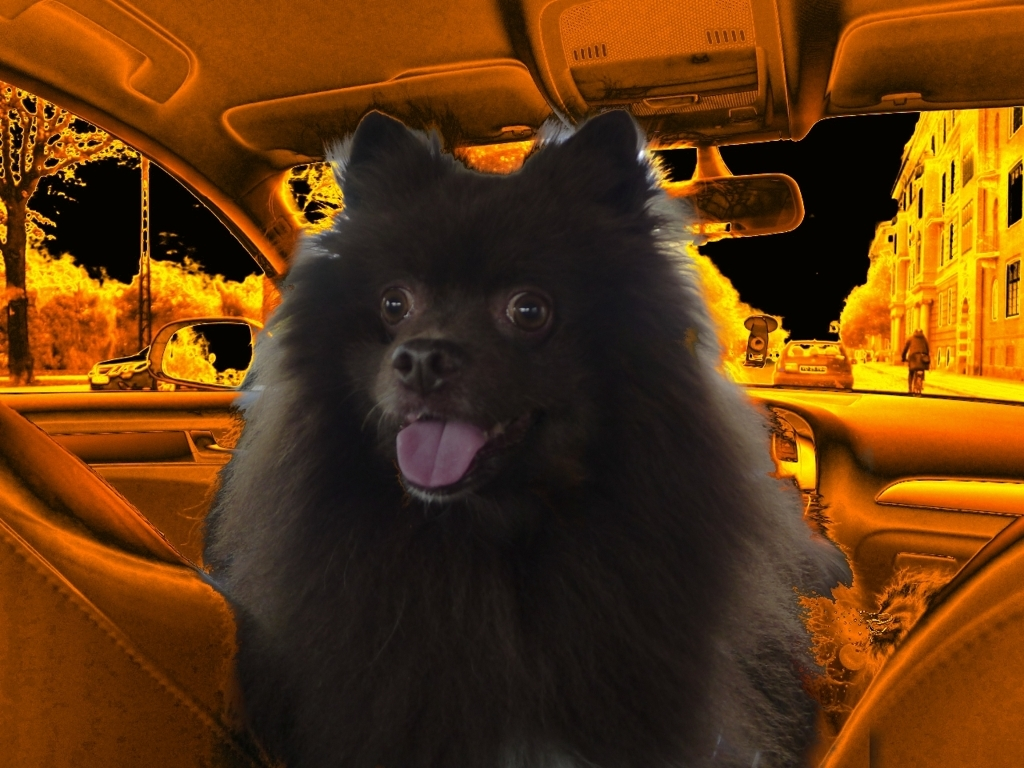This image has a very peculiar color tone. Can you explain what might have caused this? The unusual color tone in the image seems to be the result of a thermal imaging filter applied to the original photo. This filter mimics the effect of a thermal camera, highlighting the heat signature of objects and exaggerating differences in temperature, which can be visually identified by the varying intensity of orange and yellow hues across the scene. Why does the dog appear less affected by this filter compared to the rest of the environment? It's likely that the dog's fur has a different thermal profile compared to inanimate objects, such as the car's interior. Fur can insulate well, potentially leading to less thermal radiation being detected and thus a darker appearance in a thermal image. Additionally, the filter or effect applied here might have been selectively adjusted or the dog could have been superimposed into the image after the filter was applied, sparing it from the full extent of the color alteration. 